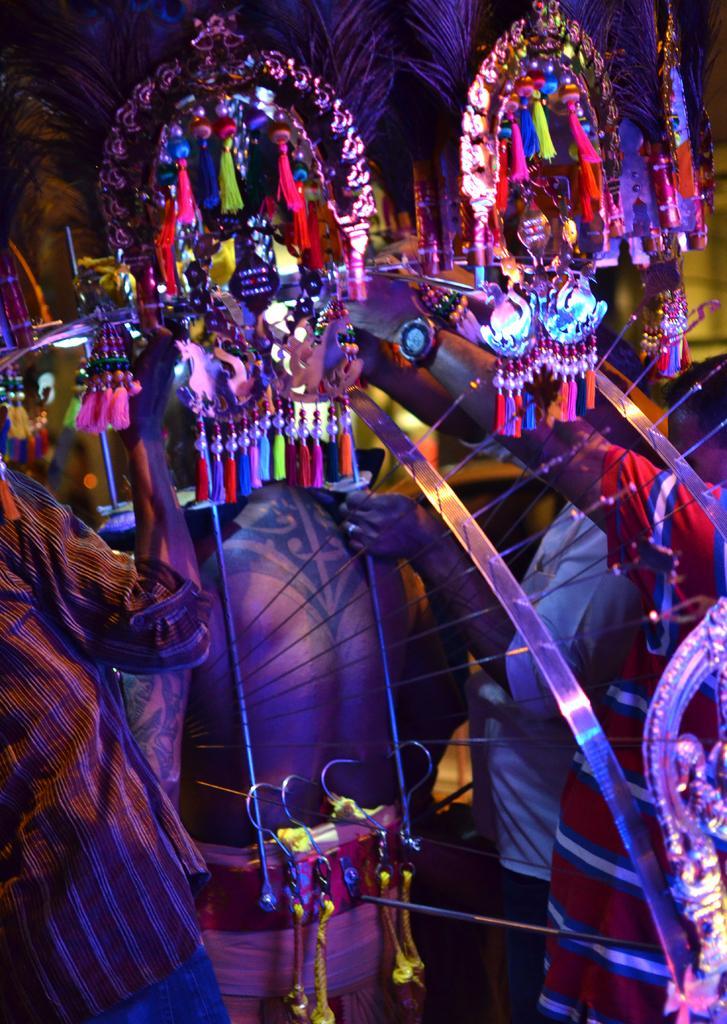How would you summarize this image in a sentence or two? In the picture we can see group of people wearing different costumes. 